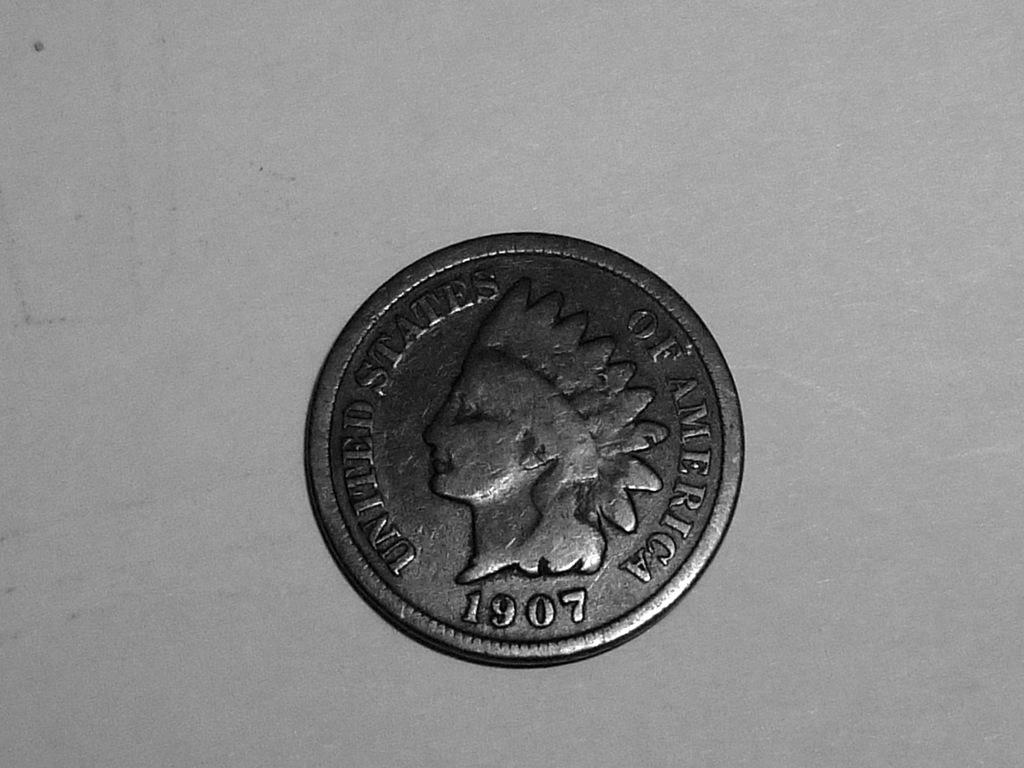<image>
Give a short and clear explanation of the subsequent image. a coin that says 1907, united states of america on it 